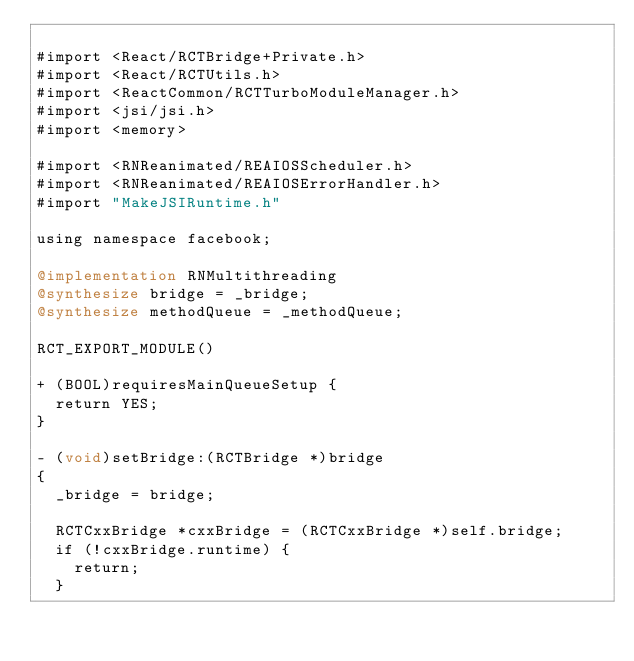<code> <loc_0><loc_0><loc_500><loc_500><_ObjectiveC_>
#import <React/RCTBridge+Private.h>
#import <React/RCTUtils.h>
#import <ReactCommon/RCTTurboModuleManager.h>
#import <jsi/jsi.h>
#import <memory>

#import <RNReanimated/REAIOSScheduler.h>
#import <RNReanimated/REAIOSErrorHandler.h>
#import "MakeJSIRuntime.h"

using namespace facebook;

@implementation RNMultithreading
@synthesize bridge = _bridge;
@synthesize methodQueue = _methodQueue;

RCT_EXPORT_MODULE()

+ (BOOL)requiresMainQueueSetup {
  return YES;
}

- (void)setBridge:(RCTBridge *)bridge
{
  _bridge = bridge;
  
  RCTCxxBridge *cxxBridge = (RCTCxxBridge *)self.bridge;
  if (!cxxBridge.runtime) {
    return;
  }
  </code> 